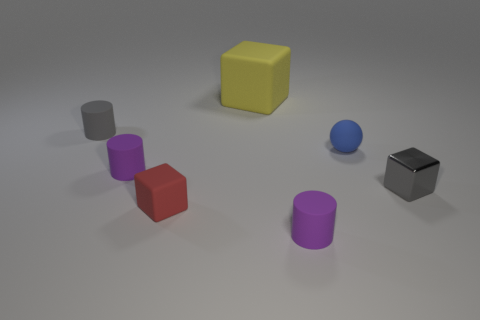What number of cylinders are the same color as the metal thing?
Provide a succinct answer. 1. Is there a tiny rubber thing that is to the right of the purple matte cylinder in front of the gray block?
Offer a terse response. Yes. Do the block that is on the right side of the big yellow rubber object and the small cylinder that is behind the blue thing have the same color?
Offer a terse response. Yes. What color is the matte cube that is the same size as the gray matte cylinder?
Give a very brief answer. Red. Are there the same number of gray objects that are behind the metallic thing and large yellow rubber things behind the small red matte cube?
Your answer should be compact. Yes. What is the tiny gray thing in front of the small matte cylinder that is behind the blue matte object made of?
Provide a succinct answer. Metal. What number of objects are gray cylinders or tiny red spheres?
Your response must be concise. 1. There is another thing that is the same color as the metallic object; what size is it?
Offer a terse response. Small. Is the number of red rubber blocks less than the number of objects?
Make the answer very short. Yes. The gray thing that is made of the same material as the small blue object is what size?
Give a very brief answer. Small. 